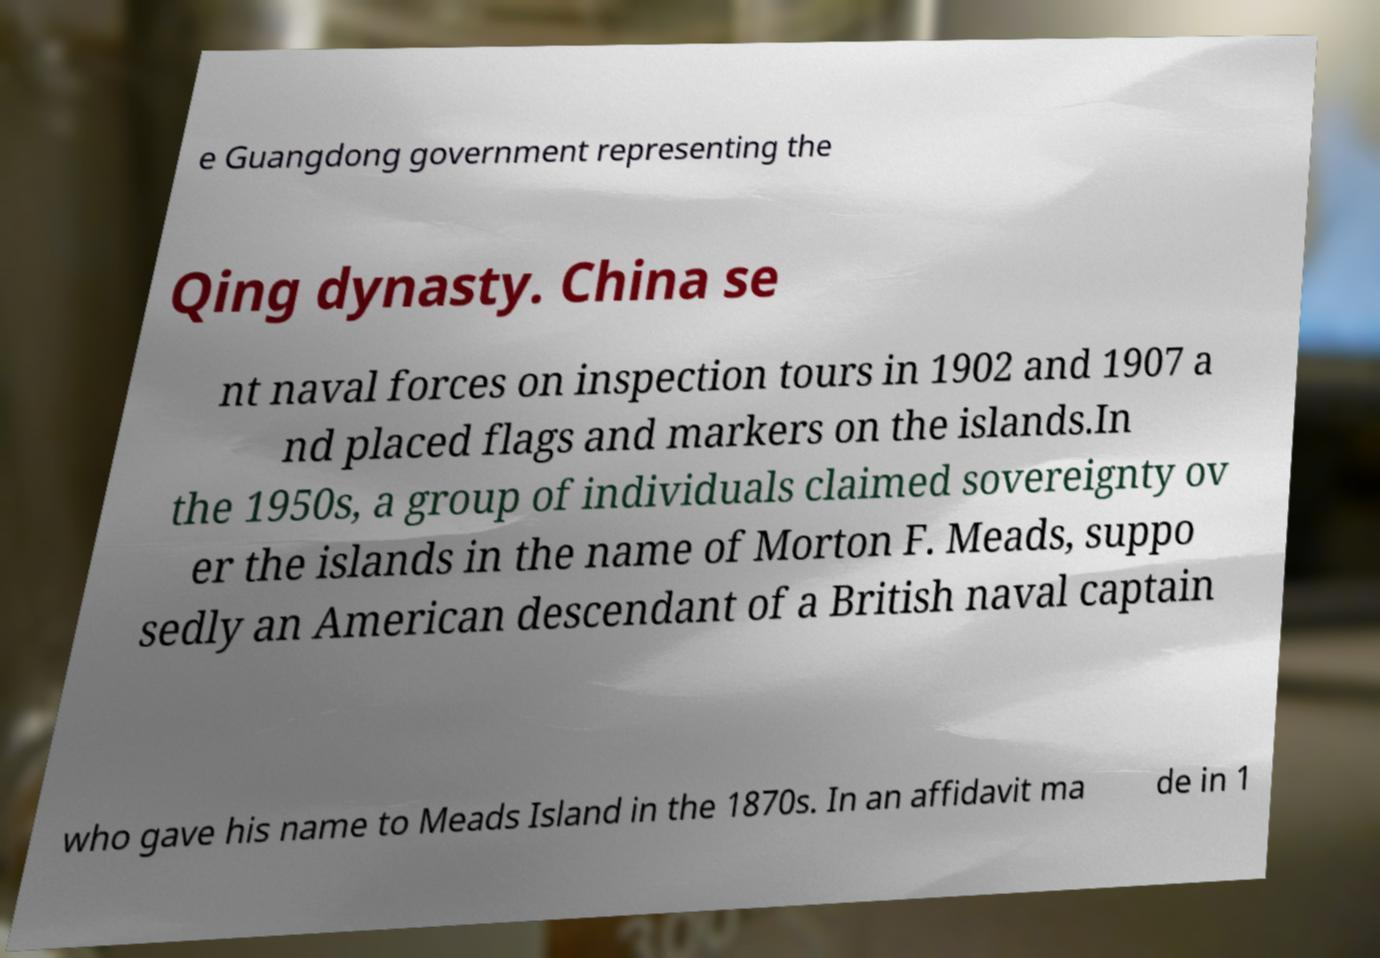Could you extract and type out the text from this image? e Guangdong government representing the Qing dynasty. China se nt naval forces on inspection tours in 1902 and 1907 a nd placed flags and markers on the islands.In the 1950s, a group of individuals claimed sovereignty ov er the islands in the name of Morton F. Meads, suppo sedly an American descendant of a British naval captain who gave his name to Meads Island in the 1870s. In an affidavit ma de in 1 